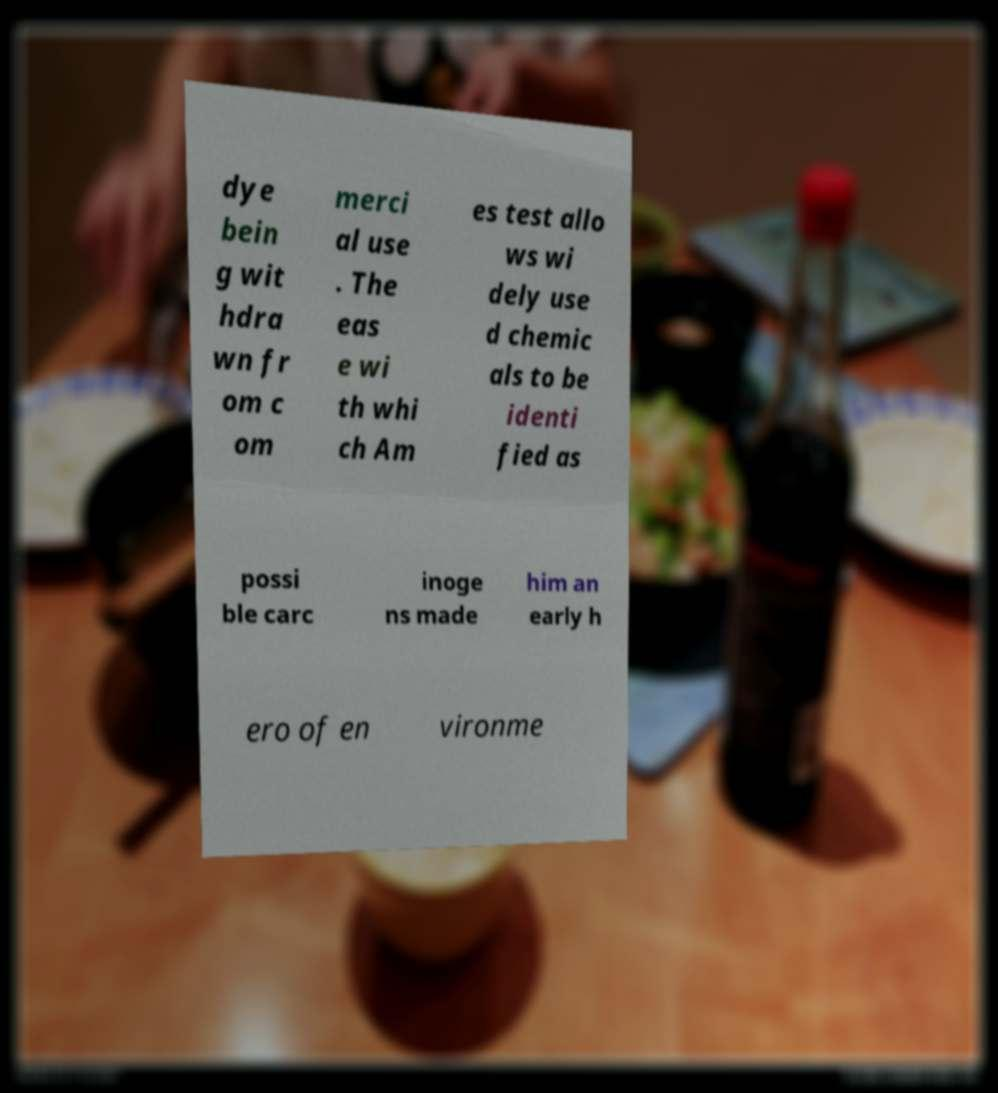There's text embedded in this image that I need extracted. Can you transcribe it verbatim? dye bein g wit hdra wn fr om c om merci al use . The eas e wi th whi ch Am es test allo ws wi dely use d chemic als to be identi fied as possi ble carc inoge ns made him an early h ero of en vironme 